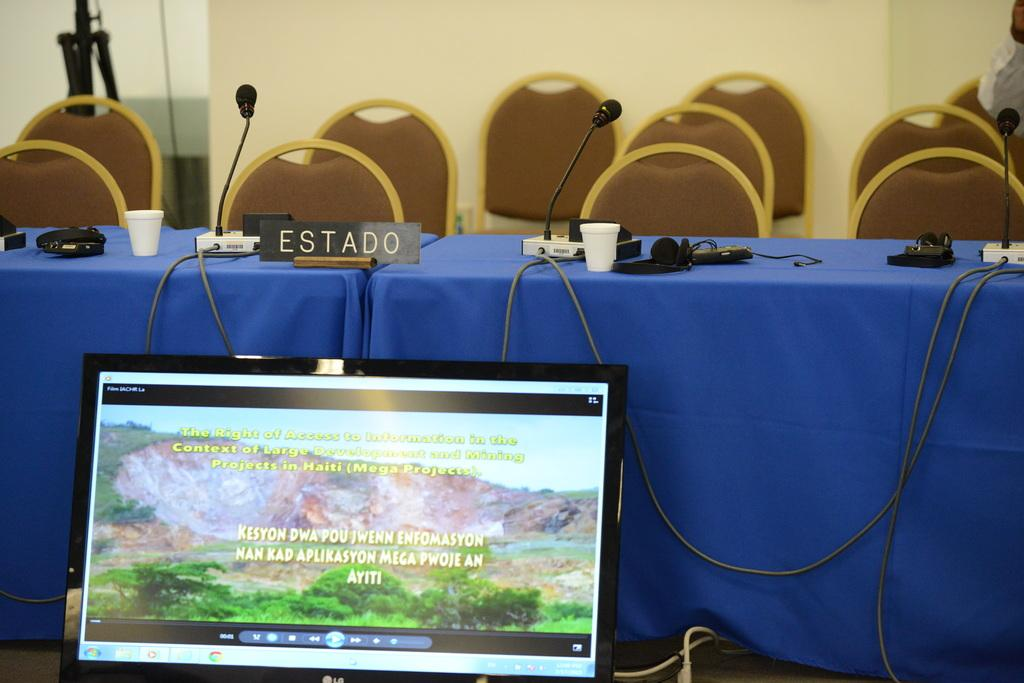<image>
Offer a succinct explanation of the picture presented. A table with a blue tablecloth has a sign that says "ESTADO" on it. 